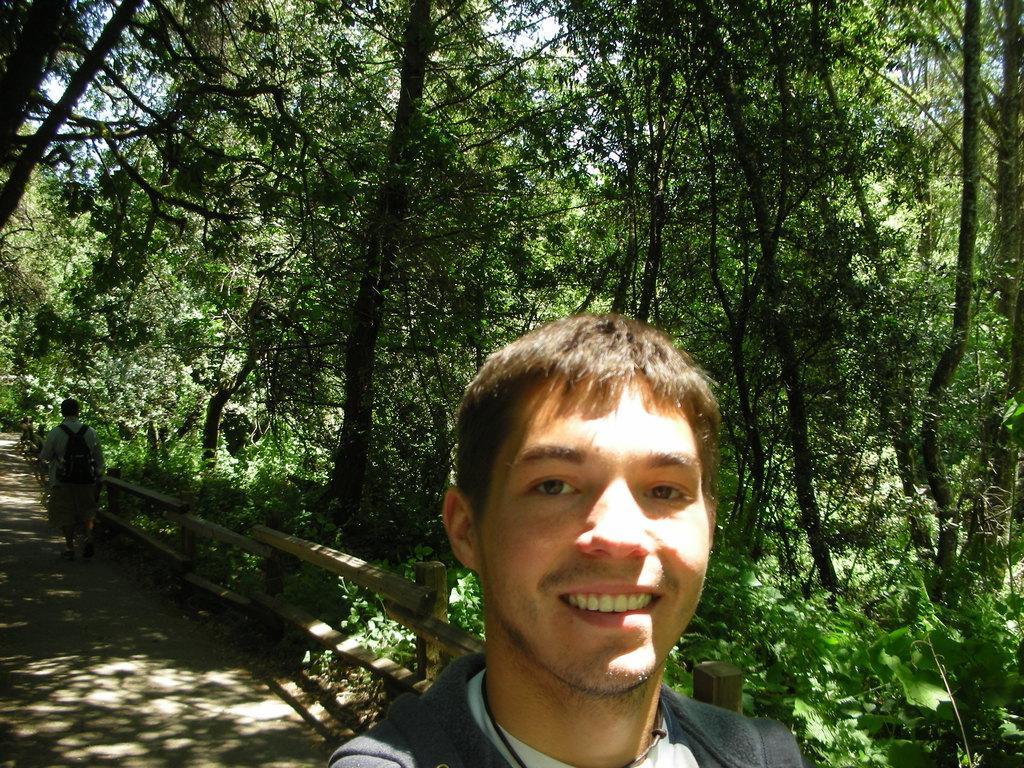Can you describe this image briefly? In this image we can see two person's, a person is walking on the road with backpack near the railing and there are few trees on the right side. 